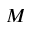<formula> <loc_0><loc_0><loc_500><loc_500>M</formula> 